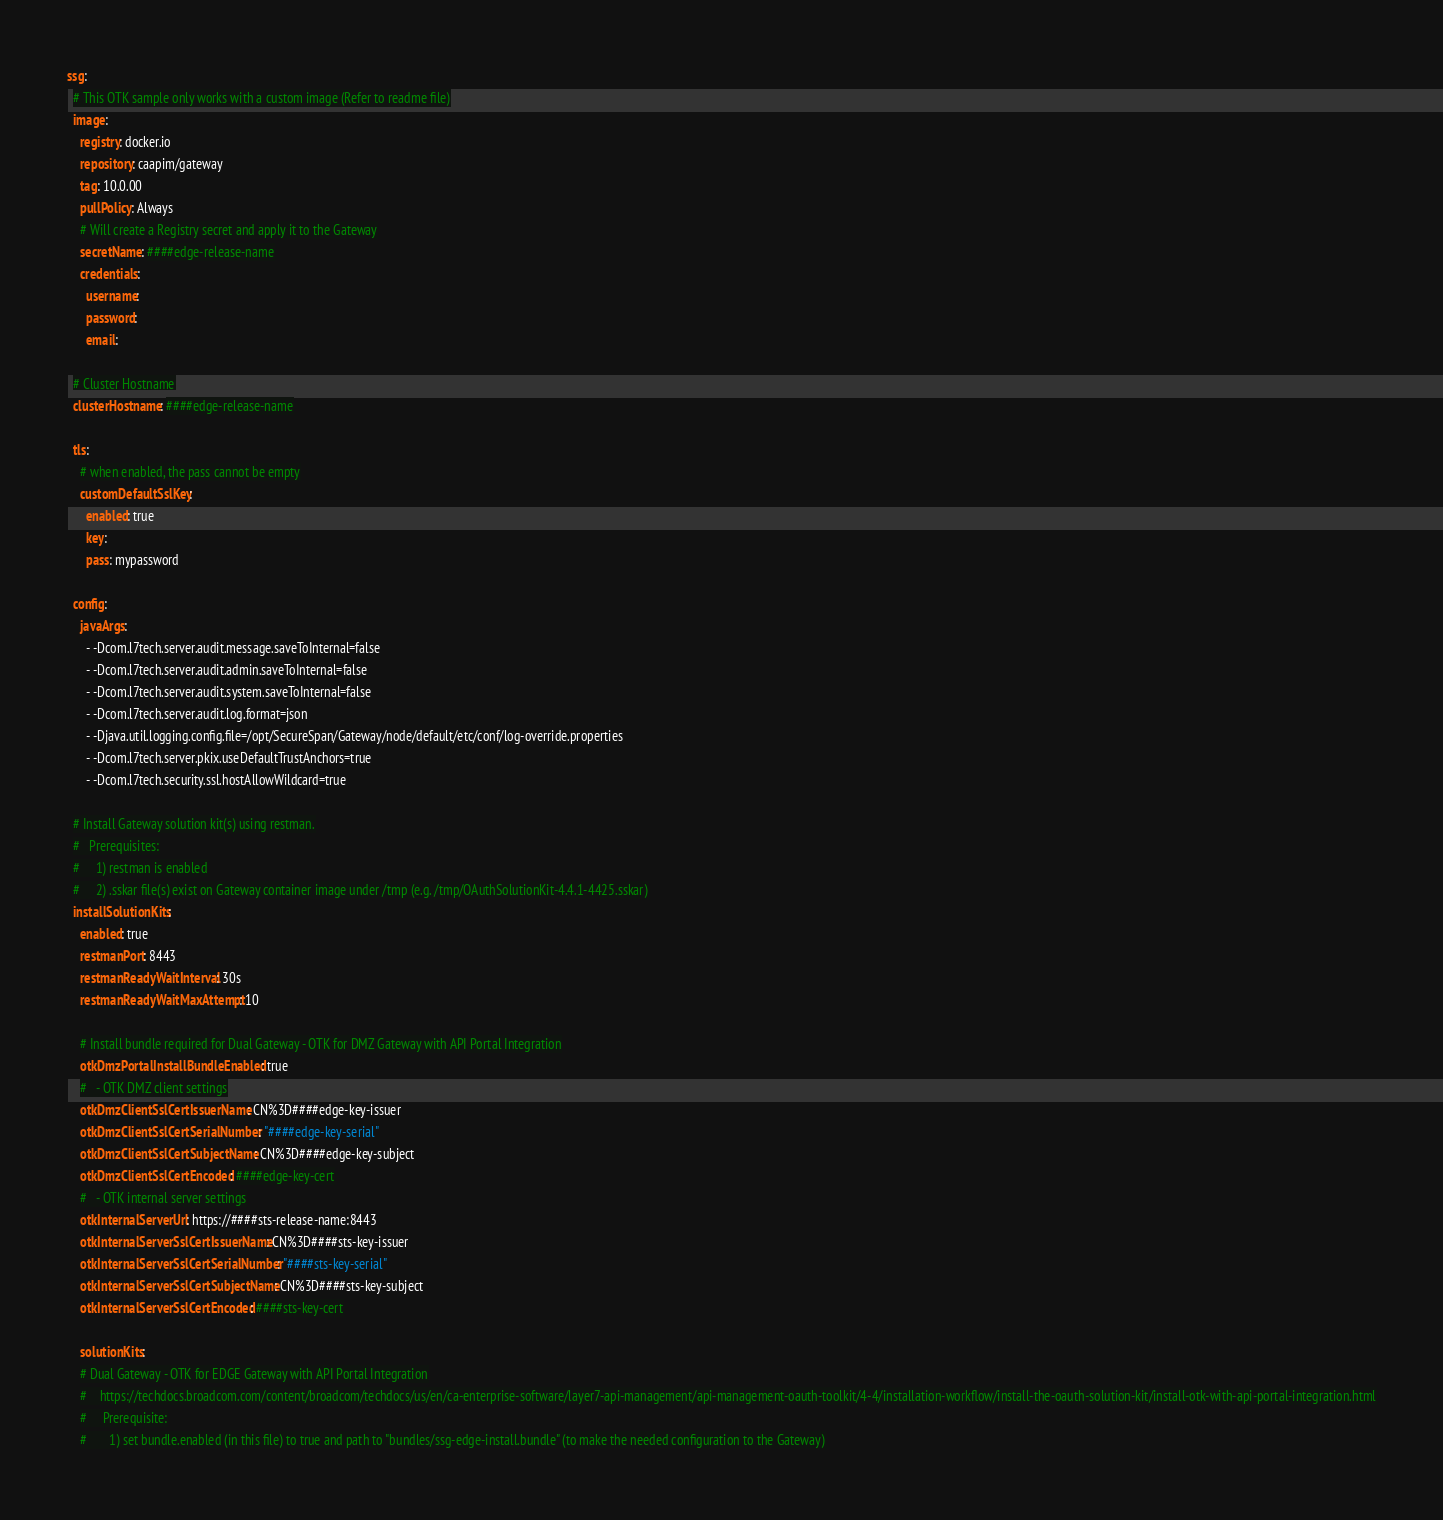Convert code to text. <code><loc_0><loc_0><loc_500><loc_500><_YAML_>ssg:
  # This OTK sample only works with a custom image (Refer to readme file)
  image:
    registry: docker.io
    repository: caapim/gateway
    tag: 10.0.00
    pullPolicy: Always
    # Will create a Registry secret and apply it to the Gateway
    secretName: ####edge-release-name
    credentials:
      username:
      password:
      email:

  # Cluster Hostname
  clusterHostname: ####edge-release-name

  tls:
    # when enabled, the pass cannot be empty
    customDefaultSslKey:
      enabled: true
      key:
      pass: mypassword

  config:
    javaArgs:
      - -Dcom.l7tech.server.audit.message.saveToInternal=false
      - -Dcom.l7tech.server.audit.admin.saveToInternal=false
      - -Dcom.l7tech.server.audit.system.saveToInternal=false
      - -Dcom.l7tech.server.audit.log.format=json
      - -Djava.util.logging.config.file=/opt/SecureSpan/Gateway/node/default/etc/conf/log-override.properties
      - -Dcom.l7tech.server.pkix.useDefaultTrustAnchors=true
      - -Dcom.l7tech.security.ssl.hostAllowWildcard=true

  # Install Gateway solution kit(s) using restman.
  #   Prerequisites:
  #     1) restman is enabled
  #     2) .sskar file(s) exist on Gateway container image under /tmp (e.g. /tmp/OAuthSolutionKit-4.4.1-4425.sskar)
  installSolutionKits:
    enabled: true
    restmanPort: 8443
    restmanReadyWaitInterval: 30s
    restmanReadyWaitMaxAttempt: 10

    # Install bundle required for Dual Gateway - OTK for DMZ Gateway with API Portal Integration
    otkDmzPortalInstallBundleEnabled: true
    #   - OTK DMZ client settings
    otkDmzClientSslCertIssuerName: CN%3D####edge-key-issuer
    otkDmzClientSslCertSerialNumber: "####edge-key-serial"
    otkDmzClientSslCertSubjectName: CN%3D####edge-key-subject
    otkDmzClientSslCertEncoded: ####edge-key-cert
    #   - OTK internal server settings
    otkInternalServerUrl: https://####sts-release-name:8443
    otkInternalServerSslCertIssuerName: CN%3D####sts-key-issuer
    otkInternalServerSslCertSerialNumber: "####sts-key-serial"
    otkInternalServerSslCertSubjectName: CN%3D####sts-key-subject
    otkInternalServerSslCertEncoded: ####sts-key-cert

    solutionKits:
    # Dual Gateway - OTK for EDGE Gateway with API Portal Integration
    #    https://techdocs.broadcom.com/content/broadcom/techdocs/us/en/ca-enterprise-software/layer7-api-management/api-management-oauth-toolkit/4-4/installation-workflow/install-the-oauth-solution-kit/install-otk-with-api-portal-integration.html
    #     Prerequisite:
    #       1) set bundle.enabled (in this file) to true and path to "bundles/ssg-edge-install.bundle" (to make the needed configuration to the Gateway)</code> 